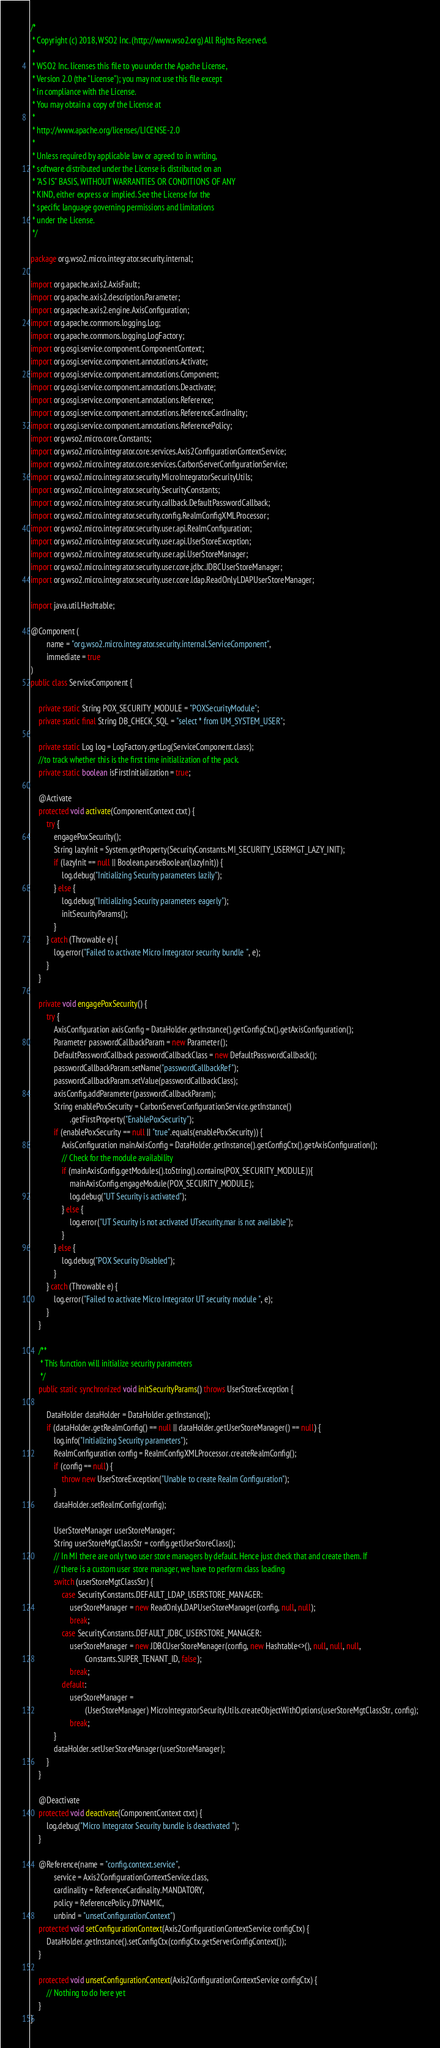Convert code to text. <code><loc_0><loc_0><loc_500><loc_500><_Java_>/*
 * Copyright (c) 2018, WSO2 Inc. (http://www.wso2.org) All Rights Reserved.
 *
 * WSO2 Inc. licenses this file to you under the Apache License,
 * Version 2.0 (the "License"); you may not use this file except
 * in compliance with the License.
 * You may obtain a copy of the License at
 *
 * http://www.apache.org/licenses/LICENSE-2.0
 *
 * Unless required by applicable law or agreed to in writing,
 * software distributed under the License is distributed on an
 * "AS IS" BASIS, WITHOUT WARRANTIES OR CONDITIONS OF ANY
 * KIND, either express or implied. See the License for the
 * specific language governing permissions and limitations
 * under the License.
 */

package org.wso2.micro.integrator.security.internal;

import org.apache.axis2.AxisFault;
import org.apache.axis2.description.Parameter;
import org.apache.axis2.engine.AxisConfiguration;
import org.apache.commons.logging.Log;
import org.apache.commons.logging.LogFactory;
import org.osgi.service.component.ComponentContext;
import org.osgi.service.component.annotations.Activate;
import org.osgi.service.component.annotations.Component;
import org.osgi.service.component.annotations.Deactivate;
import org.osgi.service.component.annotations.Reference;
import org.osgi.service.component.annotations.ReferenceCardinality;
import org.osgi.service.component.annotations.ReferencePolicy;
import org.wso2.micro.core.Constants;
import org.wso2.micro.integrator.core.services.Axis2ConfigurationContextService;
import org.wso2.micro.integrator.core.services.CarbonServerConfigurationService;
import org.wso2.micro.integrator.security.MicroIntegratorSecurityUtils;
import org.wso2.micro.integrator.security.SecurityConstants;
import org.wso2.micro.integrator.security.callback.DefaultPasswordCallback;
import org.wso2.micro.integrator.security.config.RealmConfigXMLProcessor;
import org.wso2.micro.integrator.security.user.api.RealmConfiguration;
import org.wso2.micro.integrator.security.user.api.UserStoreException;
import org.wso2.micro.integrator.security.user.api.UserStoreManager;
import org.wso2.micro.integrator.security.user.core.jdbc.JDBCUserStoreManager;
import org.wso2.micro.integrator.security.user.core.ldap.ReadOnlyLDAPUserStoreManager;

import java.util.Hashtable;

@Component (
        name = "org.wso2.micro.integrator.security.internal.ServiceComponent",
        immediate = true
)
public class ServiceComponent {

    private static String POX_SECURITY_MODULE = "POXSecurityModule";
    private static final String DB_CHECK_SQL = "select * from UM_SYSTEM_USER";

    private static Log log = LogFactory.getLog(ServiceComponent.class);
    //to track whether this is the first time initialization of the pack.
    private static boolean isFirstInitialization = true;

    @Activate
    protected void activate(ComponentContext ctxt) {
        try {
            engagePoxSecurity();
            String lazyInit = System.getProperty(SecurityConstants.MI_SECURITY_USERMGT_LAZY_INIT);
            if (lazyInit == null || Boolean.parseBoolean(lazyInit)) {
                log.debug("Initializing Security parameters lazily");
            } else {
                log.debug("Initializing Security parameters eagerly");
                initSecurityParams();
            }
        } catch (Throwable e) {
            log.error("Failed to activate Micro Integrator security bundle ", e);
        }
    }

    private void engagePoxSecurity() {
        try {
            AxisConfiguration axisConfig = DataHolder.getInstance().getConfigCtx().getAxisConfiguration();
            Parameter passwordCallbackParam = new Parameter();
            DefaultPasswordCallback passwordCallbackClass = new DefaultPasswordCallback();
            passwordCallbackParam.setName("passwordCallbackRef");
            passwordCallbackParam.setValue(passwordCallbackClass);
            axisConfig.addParameter(passwordCallbackParam);
            String enablePoxSecurity = CarbonServerConfigurationService.getInstance()
                    .getFirstProperty("EnablePoxSecurity");
            if (enablePoxSecurity == null || "true".equals(enablePoxSecurity)) {
                AxisConfiguration mainAxisConfig = DataHolder.getInstance().getConfigCtx().getAxisConfiguration();
                // Check for the module availability
                if (mainAxisConfig.getModules().toString().contains(POX_SECURITY_MODULE)){
                    mainAxisConfig.engageModule(POX_SECURITY_MODULE);
                    log.debug("UT Security is activated");
                } else {
                    log.error("UT Security is not activated UTsecurity.mar is not available");
                }
            } else {
                log.debug("POX Security Disabled");
            }
        } catch (Throwable e) {
            log.error("Failed to activate Micro Integrator UT security module ", e);
        }
    }

    /**
     * This function will initialize security parameters
     */
    public static synchronized void initSecurityParams() throws UserStoreException {

        DataHolder dataHolder = DataHolder.getInstance();
        if (dataHolder.getRealmConfig() == null || dataHolder.getUserStoreManager() == null) {
            log.info("Initializing Security parameters");
            RealmConfiguration config = RealmConfigXMLProcessor.createRealmConfig();
            if (config == null) {
                throw new UserStoreException("Unable to create Realm Configuration");
            }
            dataHolder.setRealmConfig(config);

            UserStoreManager userStoreManager;
            String userStoreMgtClassStr = config.getUserStoreClass();
            // In MI there are only two user store managers by default. Hence just check that and create them. If
            // there is a custom user store manager, we have to perform class loading
            switch (userStoreMgtClassStr) {
                case SecurityConstants.DEFAULT_LDAP_USERSTORE_MANAGER:
                    userStoreManager = new ReadOnlyLDAPUserStoreManager(config, null, null);
                    break;
                case SecurityConstants.DEFAULT_JDBC_USERSTORE_MANAGER:
                    userStoreManager = new JDBCUserStoreManager(config, new Hashtable<>(), null, null, null,
                            Constants.SUPER_TENANT_ID, false);
                    break;
                default:
                    userStoreManager =
                            (UserStoreManager) MicroIntegratorSecurityUtils.createObjectWithOptions(userStoreMgtClassStr, config);
                    break;
            }
            dataHolder.setUserStoreManager(userStoreManager);
        }
    }

    @Deactivate
    protected void deactivate(ComponentContext ctxt) {
        log.debug("Micro Integrator Security bundle is deactivated ");
    }

    @Reference(name = "config.context.service",
            service = Axis2ConfigurationContextService.class,
            cardinality = ReferenceCardinality.MANDATORY,
            policy = ReferencePolicy.DYNAMIC,
            unbind = "unsetConfigurationContext")
    protected void setConfigurationContext(Axis2ConfigurationContextService configCtx) {
        DataHolder.getInstance().setConfigCtx(configCtx.getServerConfigContext());
    }

    protected void unsetConfigurationContext(Axis2ConfigurationContextService configCtx) {
        // Nothing to do here yet
    }
}
</code> 